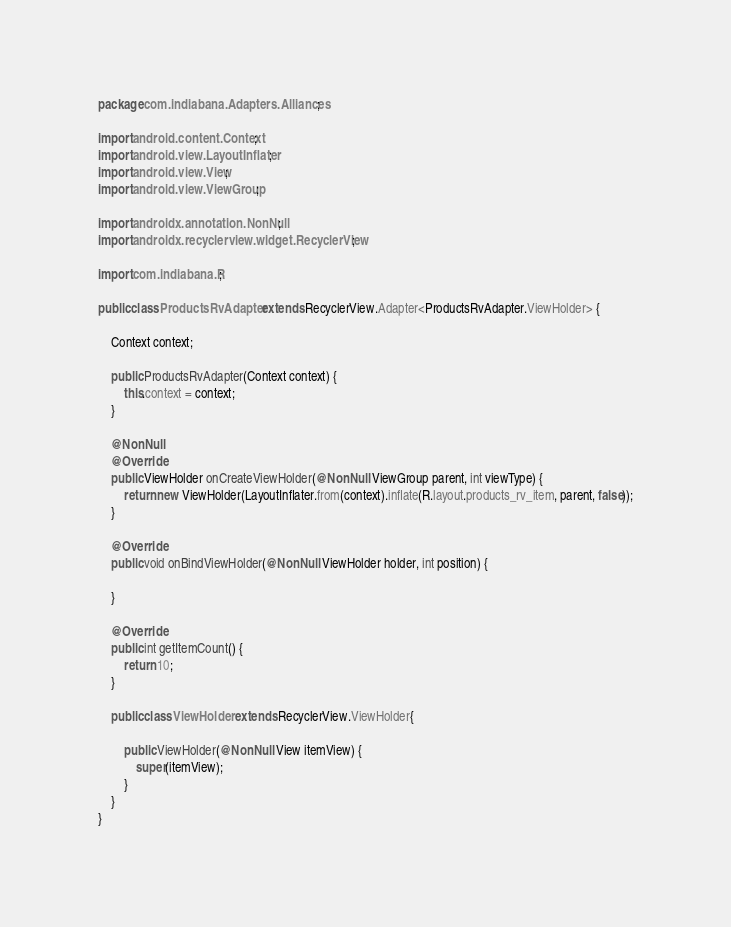<code> <loc_0><loc_0><loc_500><loc_500><_Java_>package com.indiabana.Adapters.Alliances;

import android.content.Context;
import android.view.LayoutInflater;
import android.view.View;
import android.view.ViewGroup;

import androidx.annotation.NonNull;
import androidx.recyclerview.widget.RecyclerView;

import com.indiabana.R;

public class ProductsRvAdapter extends RecyclerView.Adapter<ProductsRvAdapter.ViewHolder> {

    Context context;

    public ProductsRvAdapter(Context context) {
        this.context = context;
    }

    @NonNull
    @Override
    public ViewHolder onCreateViewHolder(@NonNull ViewGroup parent, int viewType) {
        return new ViewHolder(LayoutInflater.from(context).inflate(R.layout.products_rv_item, parent, false));
    }

    @Override
    public void onBindViewHolder(@NonNull ViewHolder holder, int position) {

    }

    @Override
    public int getItemCount() {
        return 10;
    }

    public class ViewHolder extends RecyclerView.ViewHolder{

        public ViewHolder(@NonNull View itemView) {
            super(itemView);
        }
    }
}
</code> 